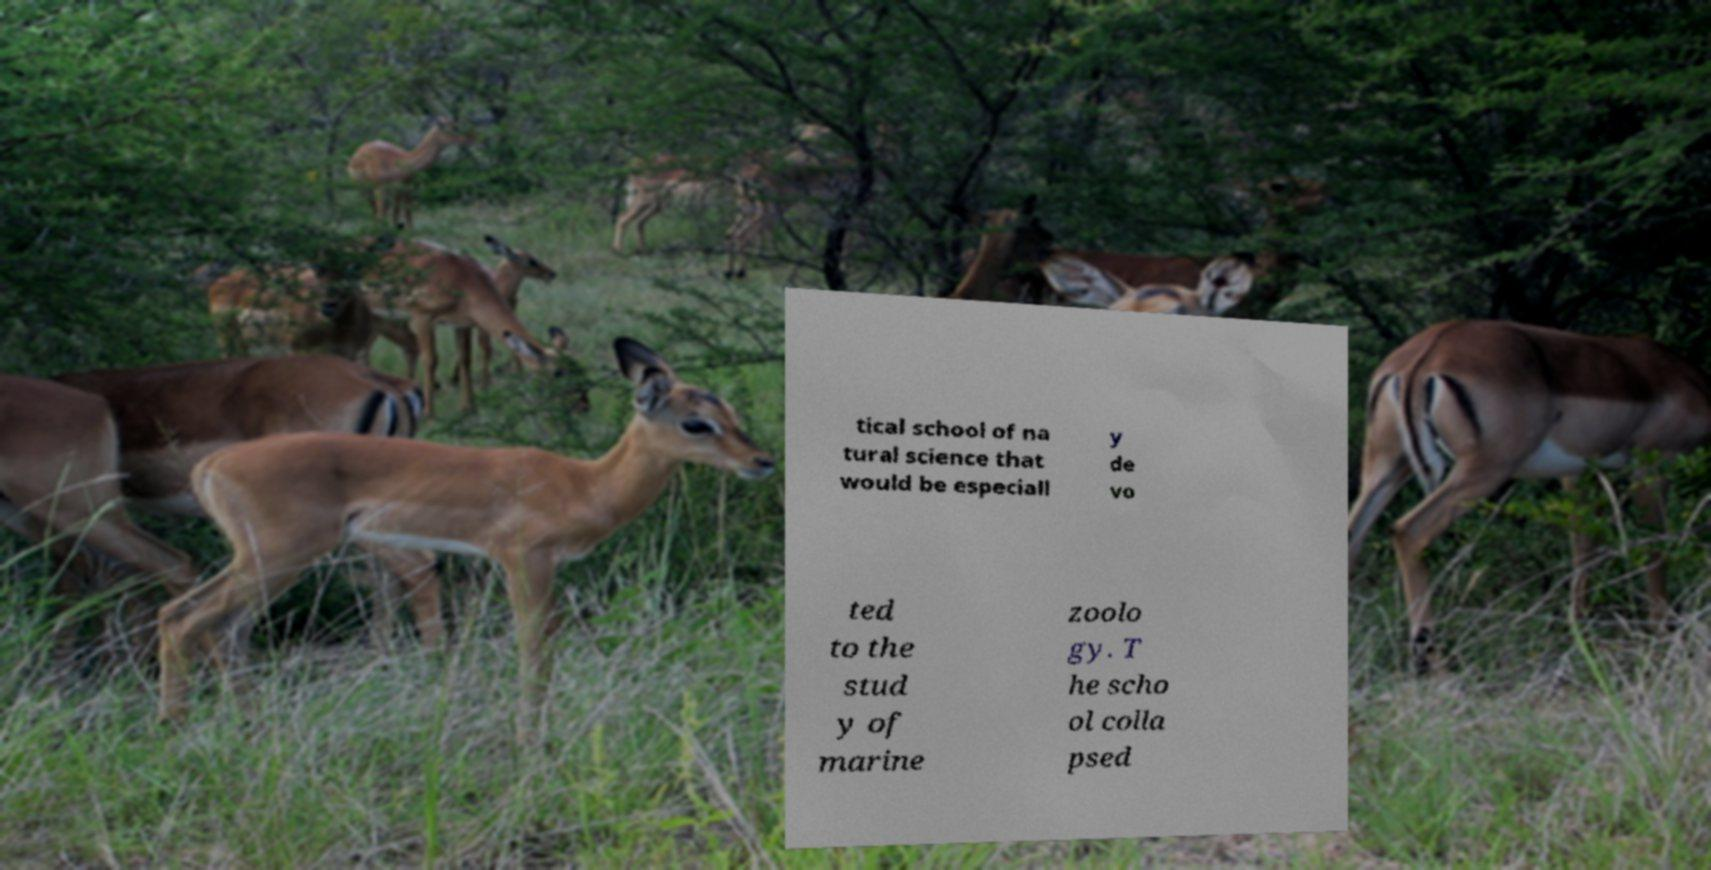I need the written content from this picture converted into text. Can you do that? tical school of na tural science that would be especiall y de vo ted to the stud y of marine zoolo gy. T he scho ol colla psed 